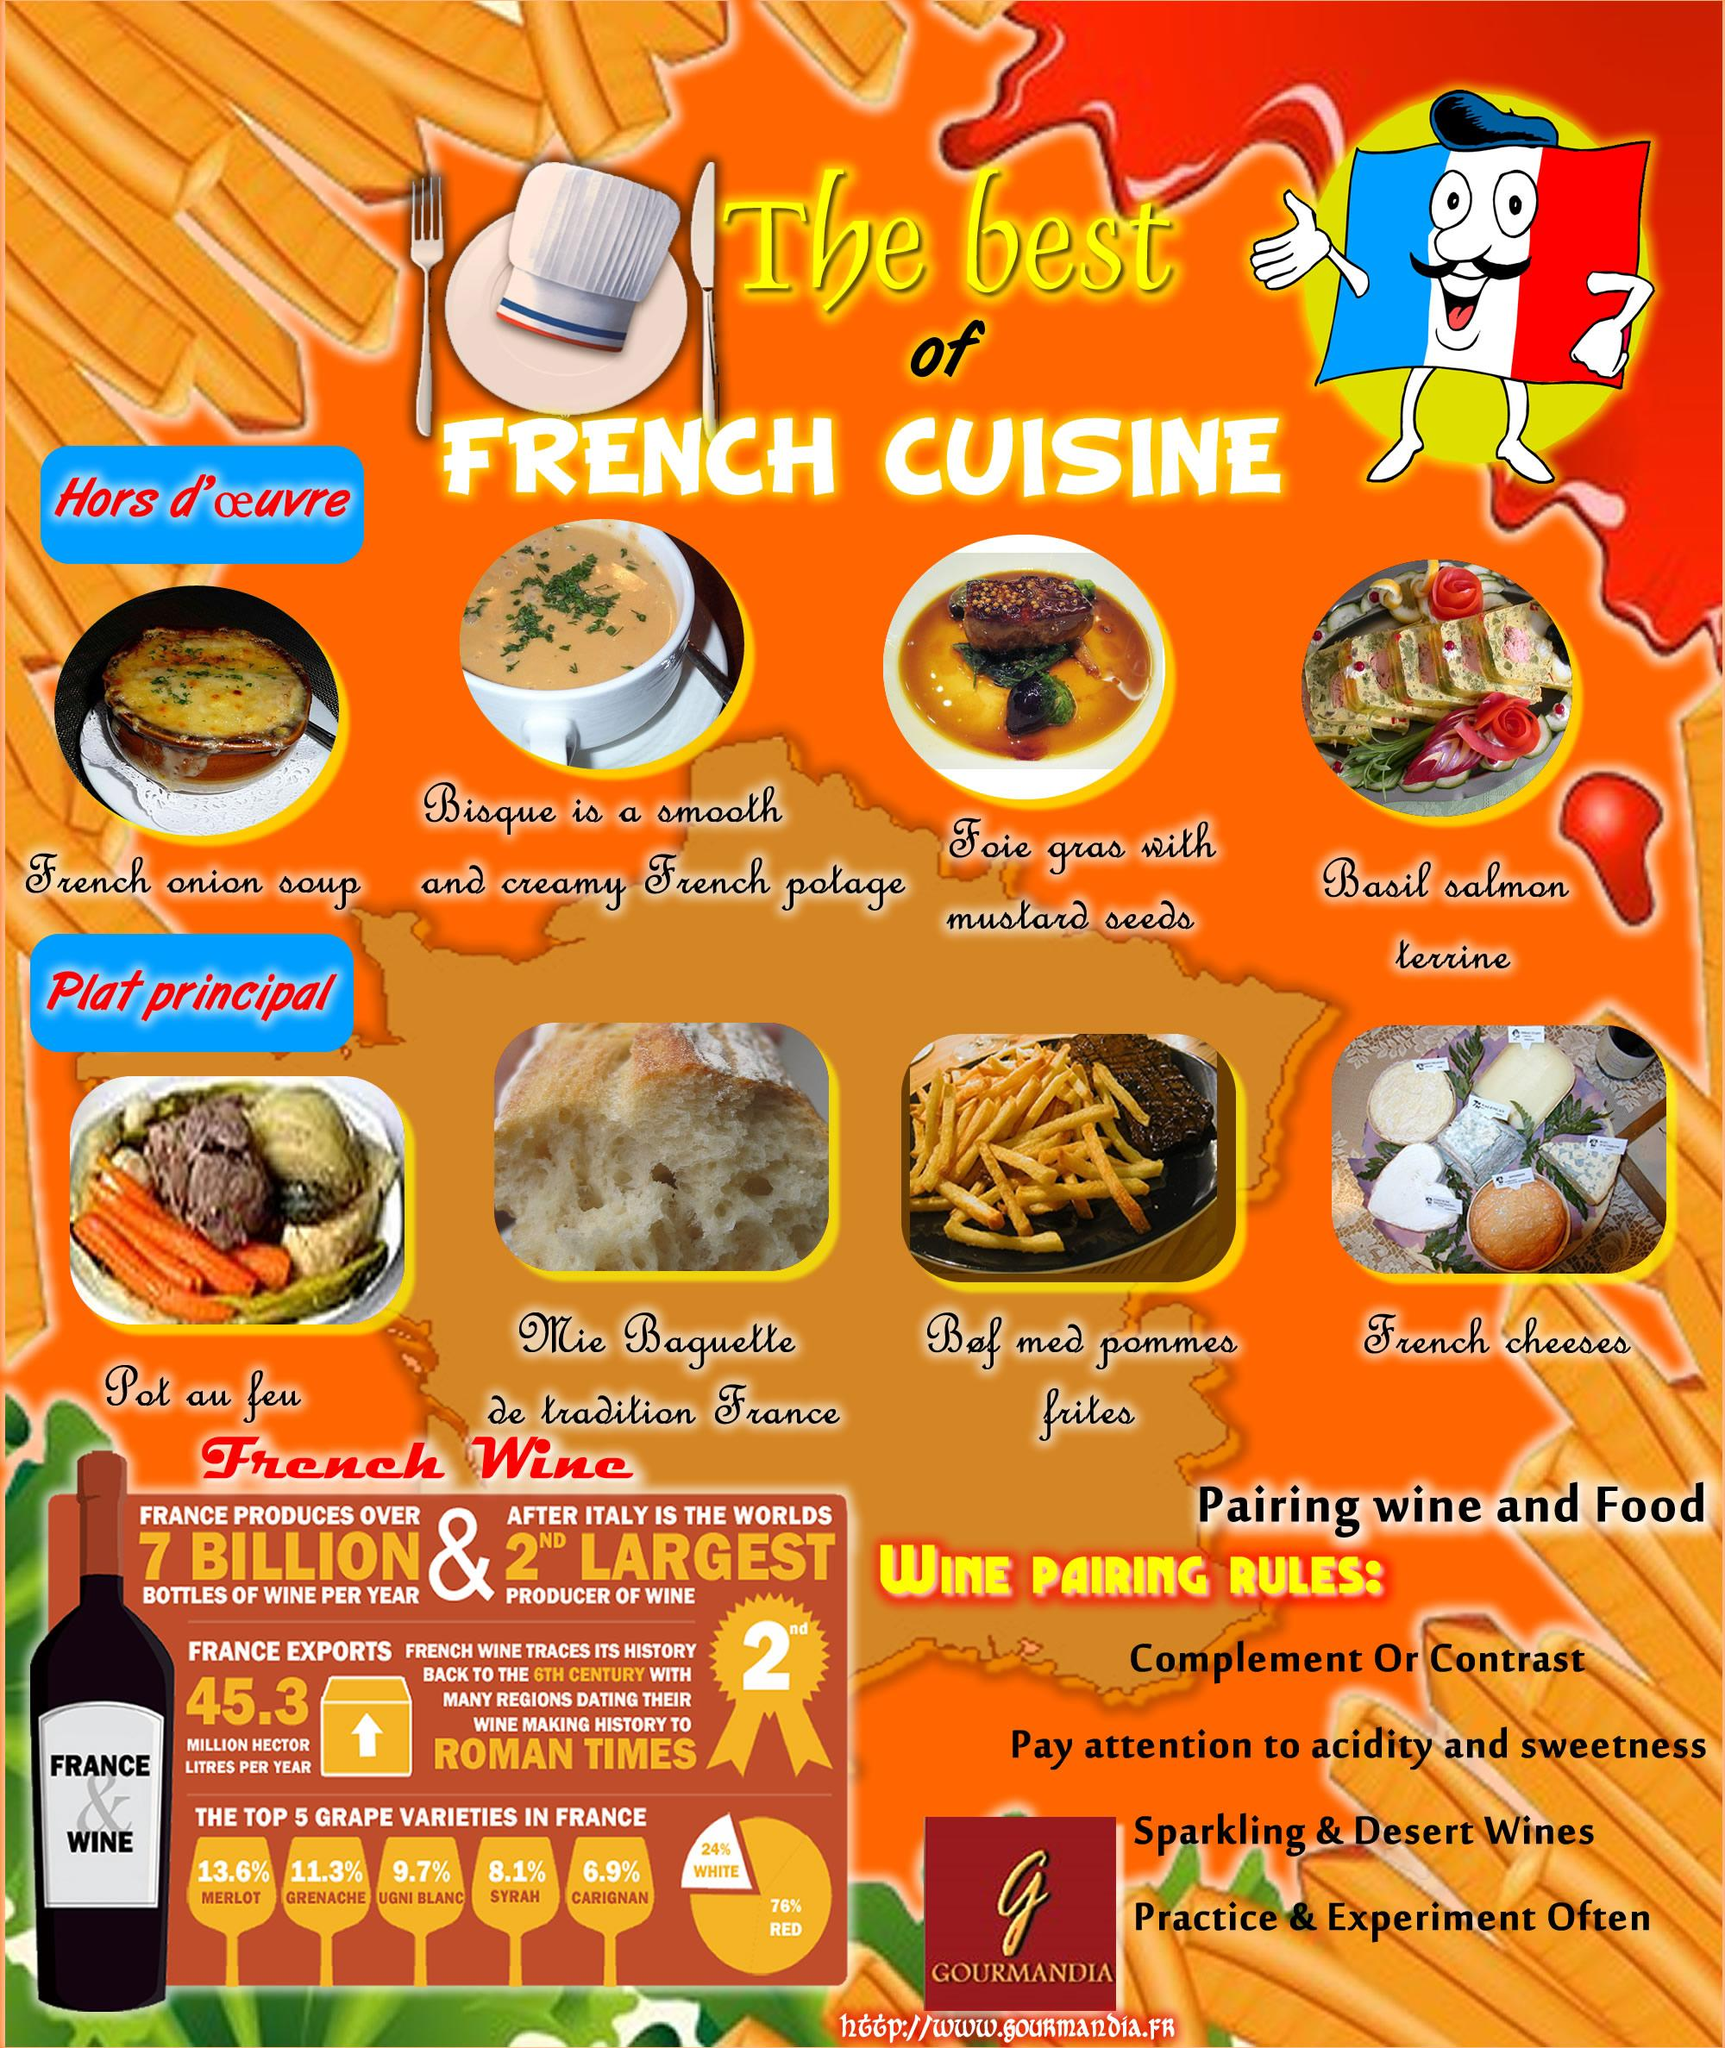Highlight a few significant elements in this photo. The following food items are prepared in a French culinary style: Four points are given under the category of "Wine Pairing Rules". The poster displays 8 different food items. Italy is the largest producer of wine in the world. The label on the bottle bears the words 'France' and 'Wine.' 